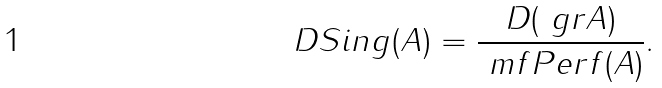<formula> <loc_0><loc_0><loc_500><loc_500>\ D S i n g ( A ) = \frac { D ( \ g r A ) } { \ m f { P e r f } ( A ) } .</formula> 